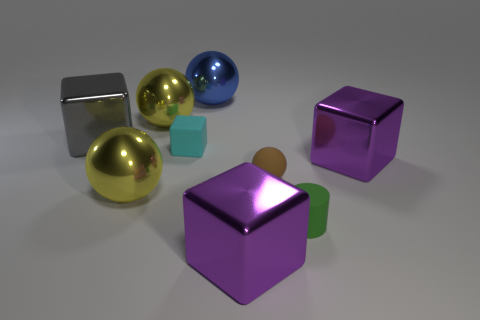Are there any other things that are the same shape as the green thing?
Offer a terse response. No. There is a purple object that is in front of the small brown matte sphere on the right side of the gray object; what is its size?
Keep it short and to the point. Large. There is a tiny object that is both left of the green thing and to the right of the blue shiny sphere; what is its color?
Ensure brevity in your answer.  Brown. There is a green cylinder that is the same size as the rubber sphere; what is it made of?
Offer a very short reply. Rubber. What number of other objects are there of the same material as the small brown object?
Provide a short and direct response. 2. There is a metal block in front of the small green matte cylinder; does it have the same color as the tiny block that is behind the rubber cylinder?
Ensure brevity in your answer.  No. The big object in front of the big yellow sphere that is in front of the rubber sphere is what shape?
Ensure brevity in your answer.  Cube. What number of other objects are there of the same color as the small rubber ball?
Provide a succinct answer. 0. Does the block that is on the right side of the green cylinder have the same material as the large ball that is on the right side of the tiny cyan thing?
Offer a terse response. Yes. There is a rubber object on the left side of the blue thing; how big is it?
Provide a short and direct response. Small. 